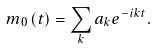Convert formula to latex. <formula><loc_0><loc_0><loc_500><loc_500>m _ { 0 } \left ( t \right ) = \sum _ { k } a _ { k } e ^ { - i k t } .</formula> 